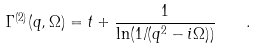Convert formula to latex. <formula><loc_0><loc_0><loc_500><loc_500>\Gamma ^ { ( 2 ) } ( { q } , \Omega ) = t + \frac { 1 } { \ln ( 1 / ( { q } ^ { 2 } - i \Omega ) ) } \quad .</formula> 